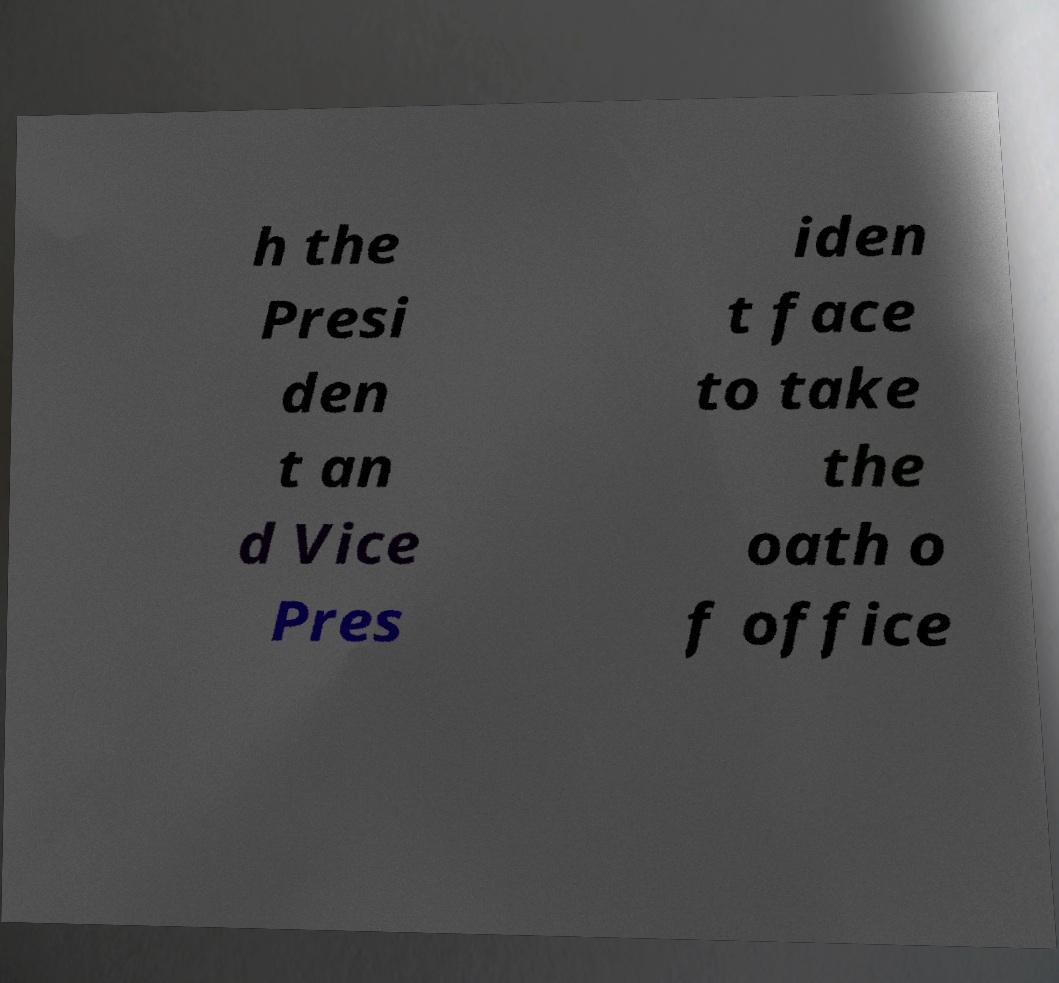For documentation purposes, I need the text within this image transcribed. Could you provide that? h the Presi den t an d Vice Pres iden t face to take the oath o f office 